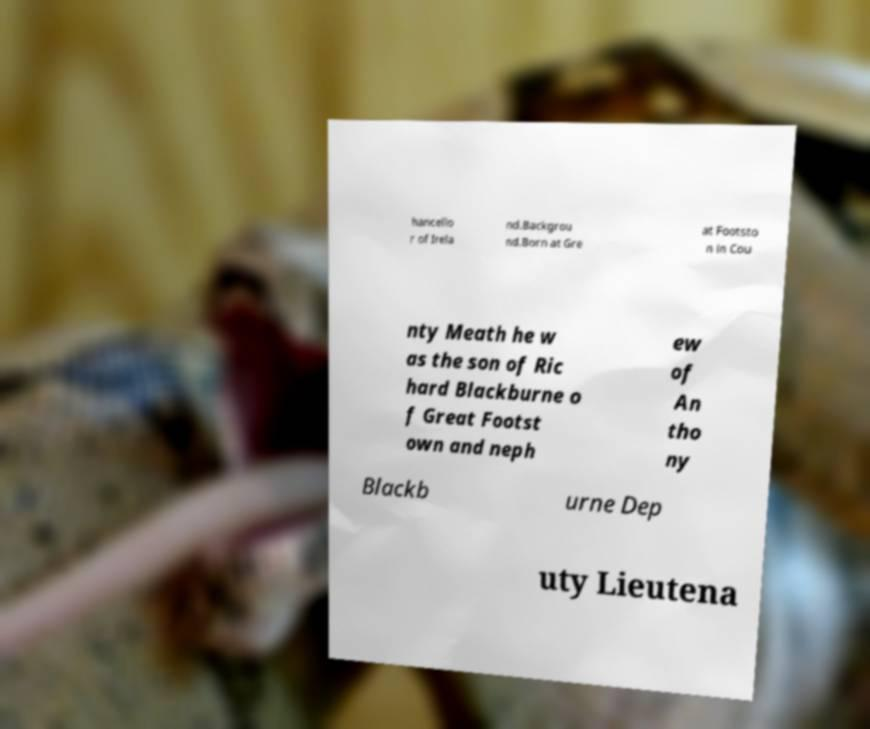Can you read and provide the text displayed in the image?This photo seems to have some interesting text. Can you extract and type it out for me? hancello r of Irela nd.Backgrou nd.Born at Gre at Footsto n in Cou nty Meath he w as the son of Ric hard Blackburne o f Great Footst own and neph ew of An tho ny Blackb urne Dep uty Lieutena 